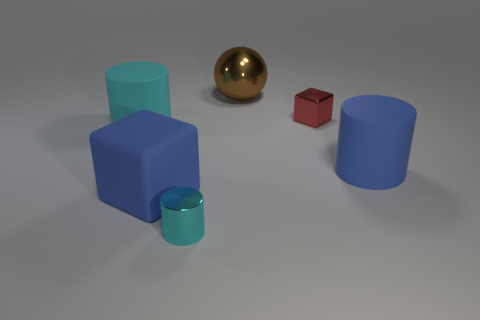Subtract all red spheres. How many cyan cylinders are left? 2 Subtract all matte cylinders. How many cylinders are left? 1 Add 4 large red metal things. How many objects exist? 10 Subtract 0 cyan blocks. How many objects are left? 6 Subtract all balls. How many objects are left? 5 Subtract all large brown metallic objects. Subtract all cyan cylinders. How many objects are left? 3 Add 5 shiny cubes. How many shiny cubes are left? 6 Add 2 blue matte cubes. How many blue matte cubes exist? 3 